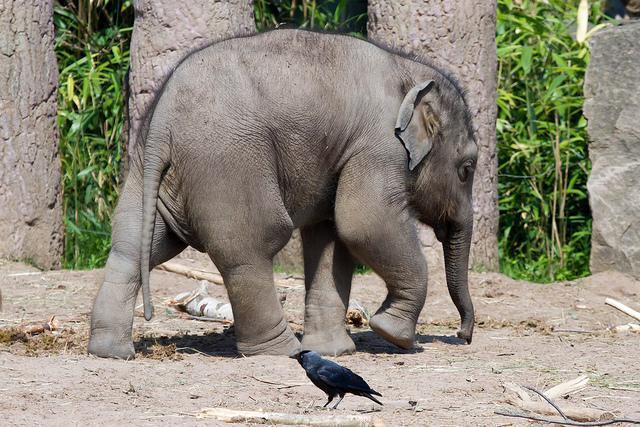How many animals are there?
Give a very brief answer. 2. How many people are wearing black shirt?
Give a very brief answer. 0. 